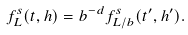Convert formula to latex. <formula><loc_0><loc_0><loc_500><loc_500>f _ { L } ^ { s } ( t , h ) = b ^ { - d } f _ { L / b } ^ { s } ( t ^ { \prime } , h ^ { \prime } ) .</formula> 